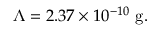Convert formula to latex. <formula><loc_0><loc_0><loc_500><loc_500>\Lambda = 2 . 3 7 \times 1 0 ^ { - 1 0 } \ g .</formula> 